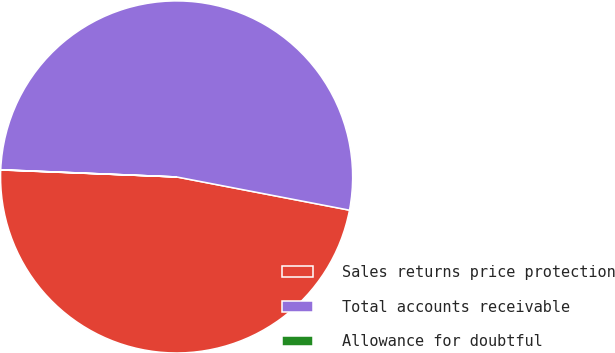<chart> <loc_0><loc_0><loc_500><loc_500><pie_chart><fcel>Sales returns price protection<fcel>Total accounts receivable<fcel>Allowance for doubtful<nl><fcel>47.61%<fcel>52.37%<fcel>0.02%<nl></chart> 